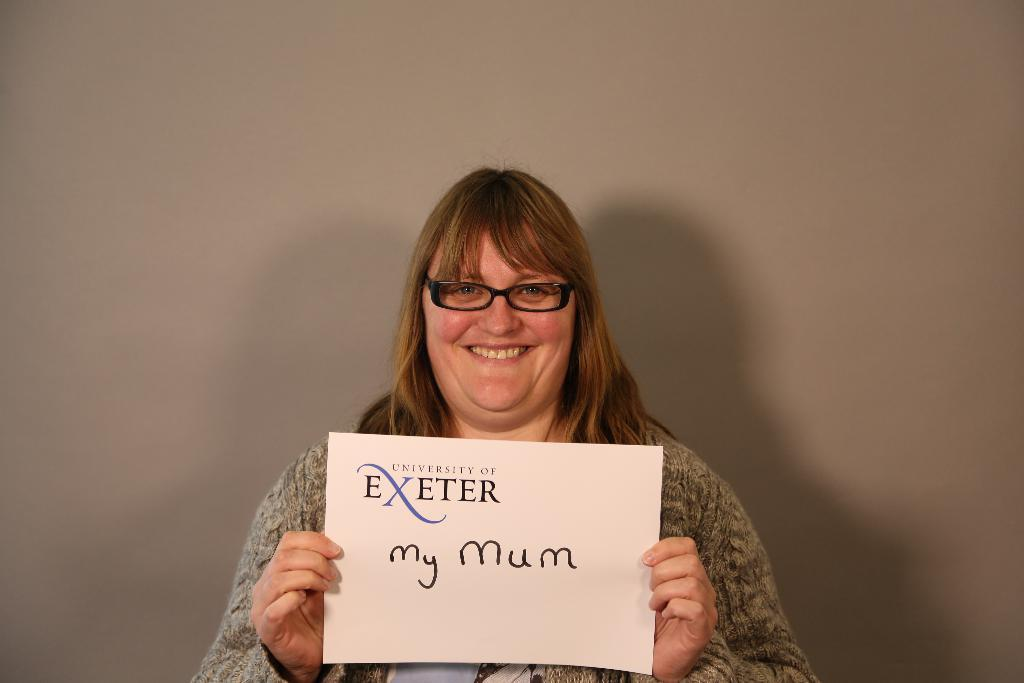Who is the main subject in the image? There is a woman in the image. What is the woman holding in the image? The woman is holding a poster. Can you describe the woman's appearance in the image? The woman is wearing spectacles. What type of bushes can be seen growing near the woman in the image? There are no bushes visible in the image; it only features a woman holding a poster and wearing spectacles. 